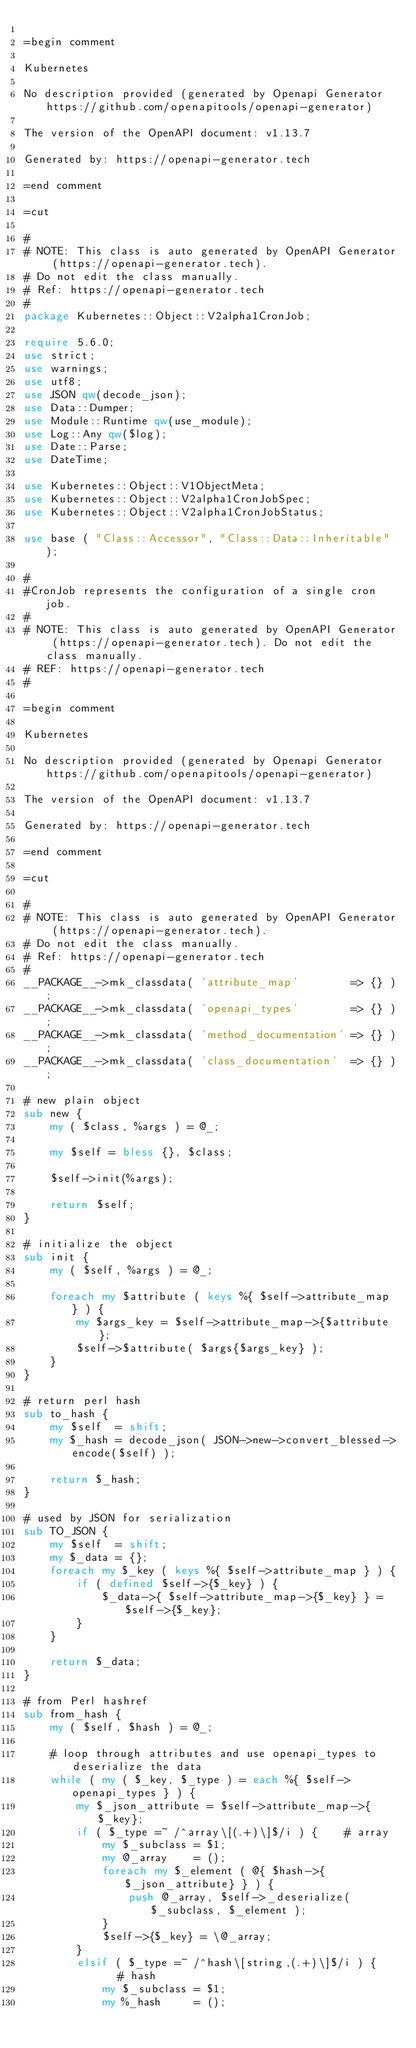<code> <loc_0><loc_0><loc_500><loc_500><_Perl_>
=begin comment

Kubernetes

No description provided (generated by Openapi Generator https://github.com/openapitools/openapi-generator)

The version of the OpenAPI document: v1.13.7

Generated by: https://openapi-generator.tech

=end comment

=cut

#
# NOTE: This class is auto generated by OpenAPI Generator (https://openapi-generator.tech).
# Do not edit the class manually.
# Ref: https://openapi-generator.tech
#
package Kubernetes::Object::V2alpha1CronJob;

require 5.6.0;
use strict;
use warnings;
use utf8;
use JSON qw(decode_json);
use Data::Dumper;
use Module::Runtime qw(use_module);
use Log::Any qw($log);
use Date::Parse;
use DateTime;

use Kubernetes::Object::V1ObjectMeta;
use Kubernetes::Object::V2alpha1CronJobSpec;
use Kubernetes::Object::V2alpha1CronJobStatus;

use base ( "Class::Accessor", "Class::Data::Inheritable" );

#
#CronJob represents the configuration of a single cron job.
#
# NOTE: This class is auto generated by OpenAPI Generator (https://openapi-generator.tech). Do not edit the class manually.
# REF: https://openapi-generator.tech
#

=begin comment

Kubernetes

No description provided (generated by Openapi Generator https://github.com/openapitools/openapi-generator)

The version of the OpenAPI document: v1.13.7

Generated by: https://openapi-generator.tech

=end comment

=cut

#
# NOTE: This class is auto generated by OpenAPI Generator (https://openapi-generator.tech).
# Do not edit the class manually.
# Ref: https://openapi-generator.tech
#
__PACKAGE__->mk_classdata( 'attribute_map'        => {} );
__PACKAGE__->mk_classdata( 'openapi_types'        => {} );
__PACKAGE__->mk_classdata( 'method_documentation' => {} );
__PACKAGE__->mk_classdata( 'class_documentation'  => {} );

# new plain object
sub new {
    my ( $class, %args ) = @_;

    my $self = bless {}, $class;

    $self->init(%args);

    return $self;
}

# initialize the object
sub init {
    my ( $self, %args ) = @_;

    foreach my $attribute ( keys %{ $self->attribute_map } ) {
        my $args_key = $self->attribute_map->{$attribute};
        $self->$attribute( $args{$args_key} );
    }
}

# return perl hash
sub to_hash {
    my $self  = shift;
    my $_hash = decode_json( JSON->new->convert_blessed->encode($self) );

    return $_hash;
}

# used by JSON for serialization
sub TO_JSON {
    my $self  = shift;
    my $_data = {};
    foreach my $_key ( keys %{ $self->attribute_map } ) {
        if ( defined $self->{$_key} ) {
            $_data->{ $self->attribute_map->{$_key} } = $self->{$_key};
        }
    }

    return $_data;
}

# from Perl hashref
sub from_hash {
    my ( $self, $hash ) = @_;

    # loop through attributes and use openapi_types to deserialize the data
    while ( my ( $_key, $_type ) = each %{ $self->openapi_types } ) {
        my $_json_attribute = $self->attribute_map->{$_key};
        if ( $_type =~ /^array\[(.+)\]$/i ) {    # array
            my $_subclass = $1;
            my @_array    = ();
            foreach my $_element ( @{ $hash->{$_json_attribute} } ) {
                push @_array, $self->_deserialize( $_subclass, $_element );
            }
            $self->{$_key} = \@_array;
        }
        elsif ( $_type =~ /^hash\[string,(.+)\]$/i ) {    # hash
            my $_subclass = $1;
            my %_hash     = ();</code> 